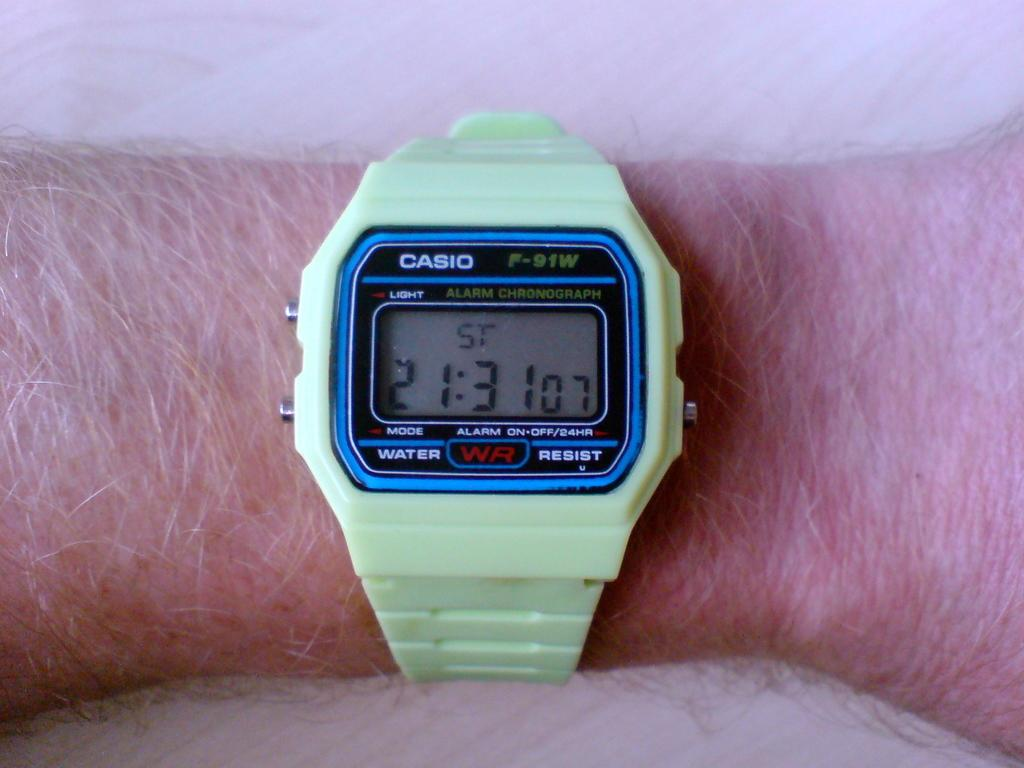Provide a one-sentence caption for the provided image. arm with a light green casio digital watch showing time at 21:31. 